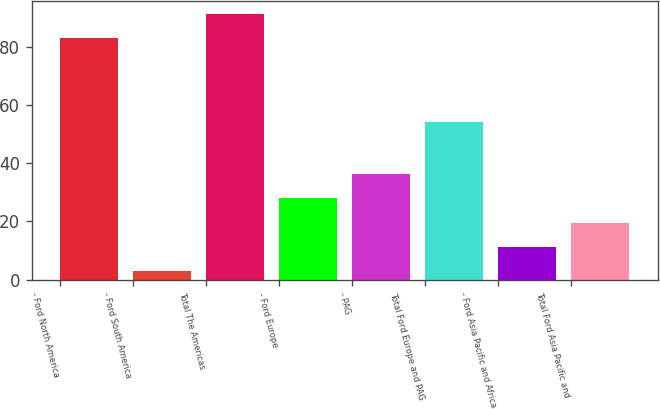<chart> <loc_0><loc_0><loc_500><loc_500><bar_chart><fcel>- Ford North America<fcel>- Ford South America<fcel>Total The Americas<fcel>- Ford Europe<fcel>- PAG<fcel>Total Ford Europe and PAG<fcel>- Ford Asia Pacific and Africa<fcel>Total Ford Asia Pacific and<nl><fcel>83<fcel>3<fcel>91.3<fcel>27.9<fcel>36.2<fcel>54.1<fcel>11.3<fcel>19.6<nl></chart> 